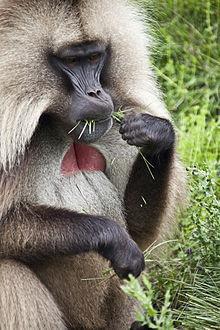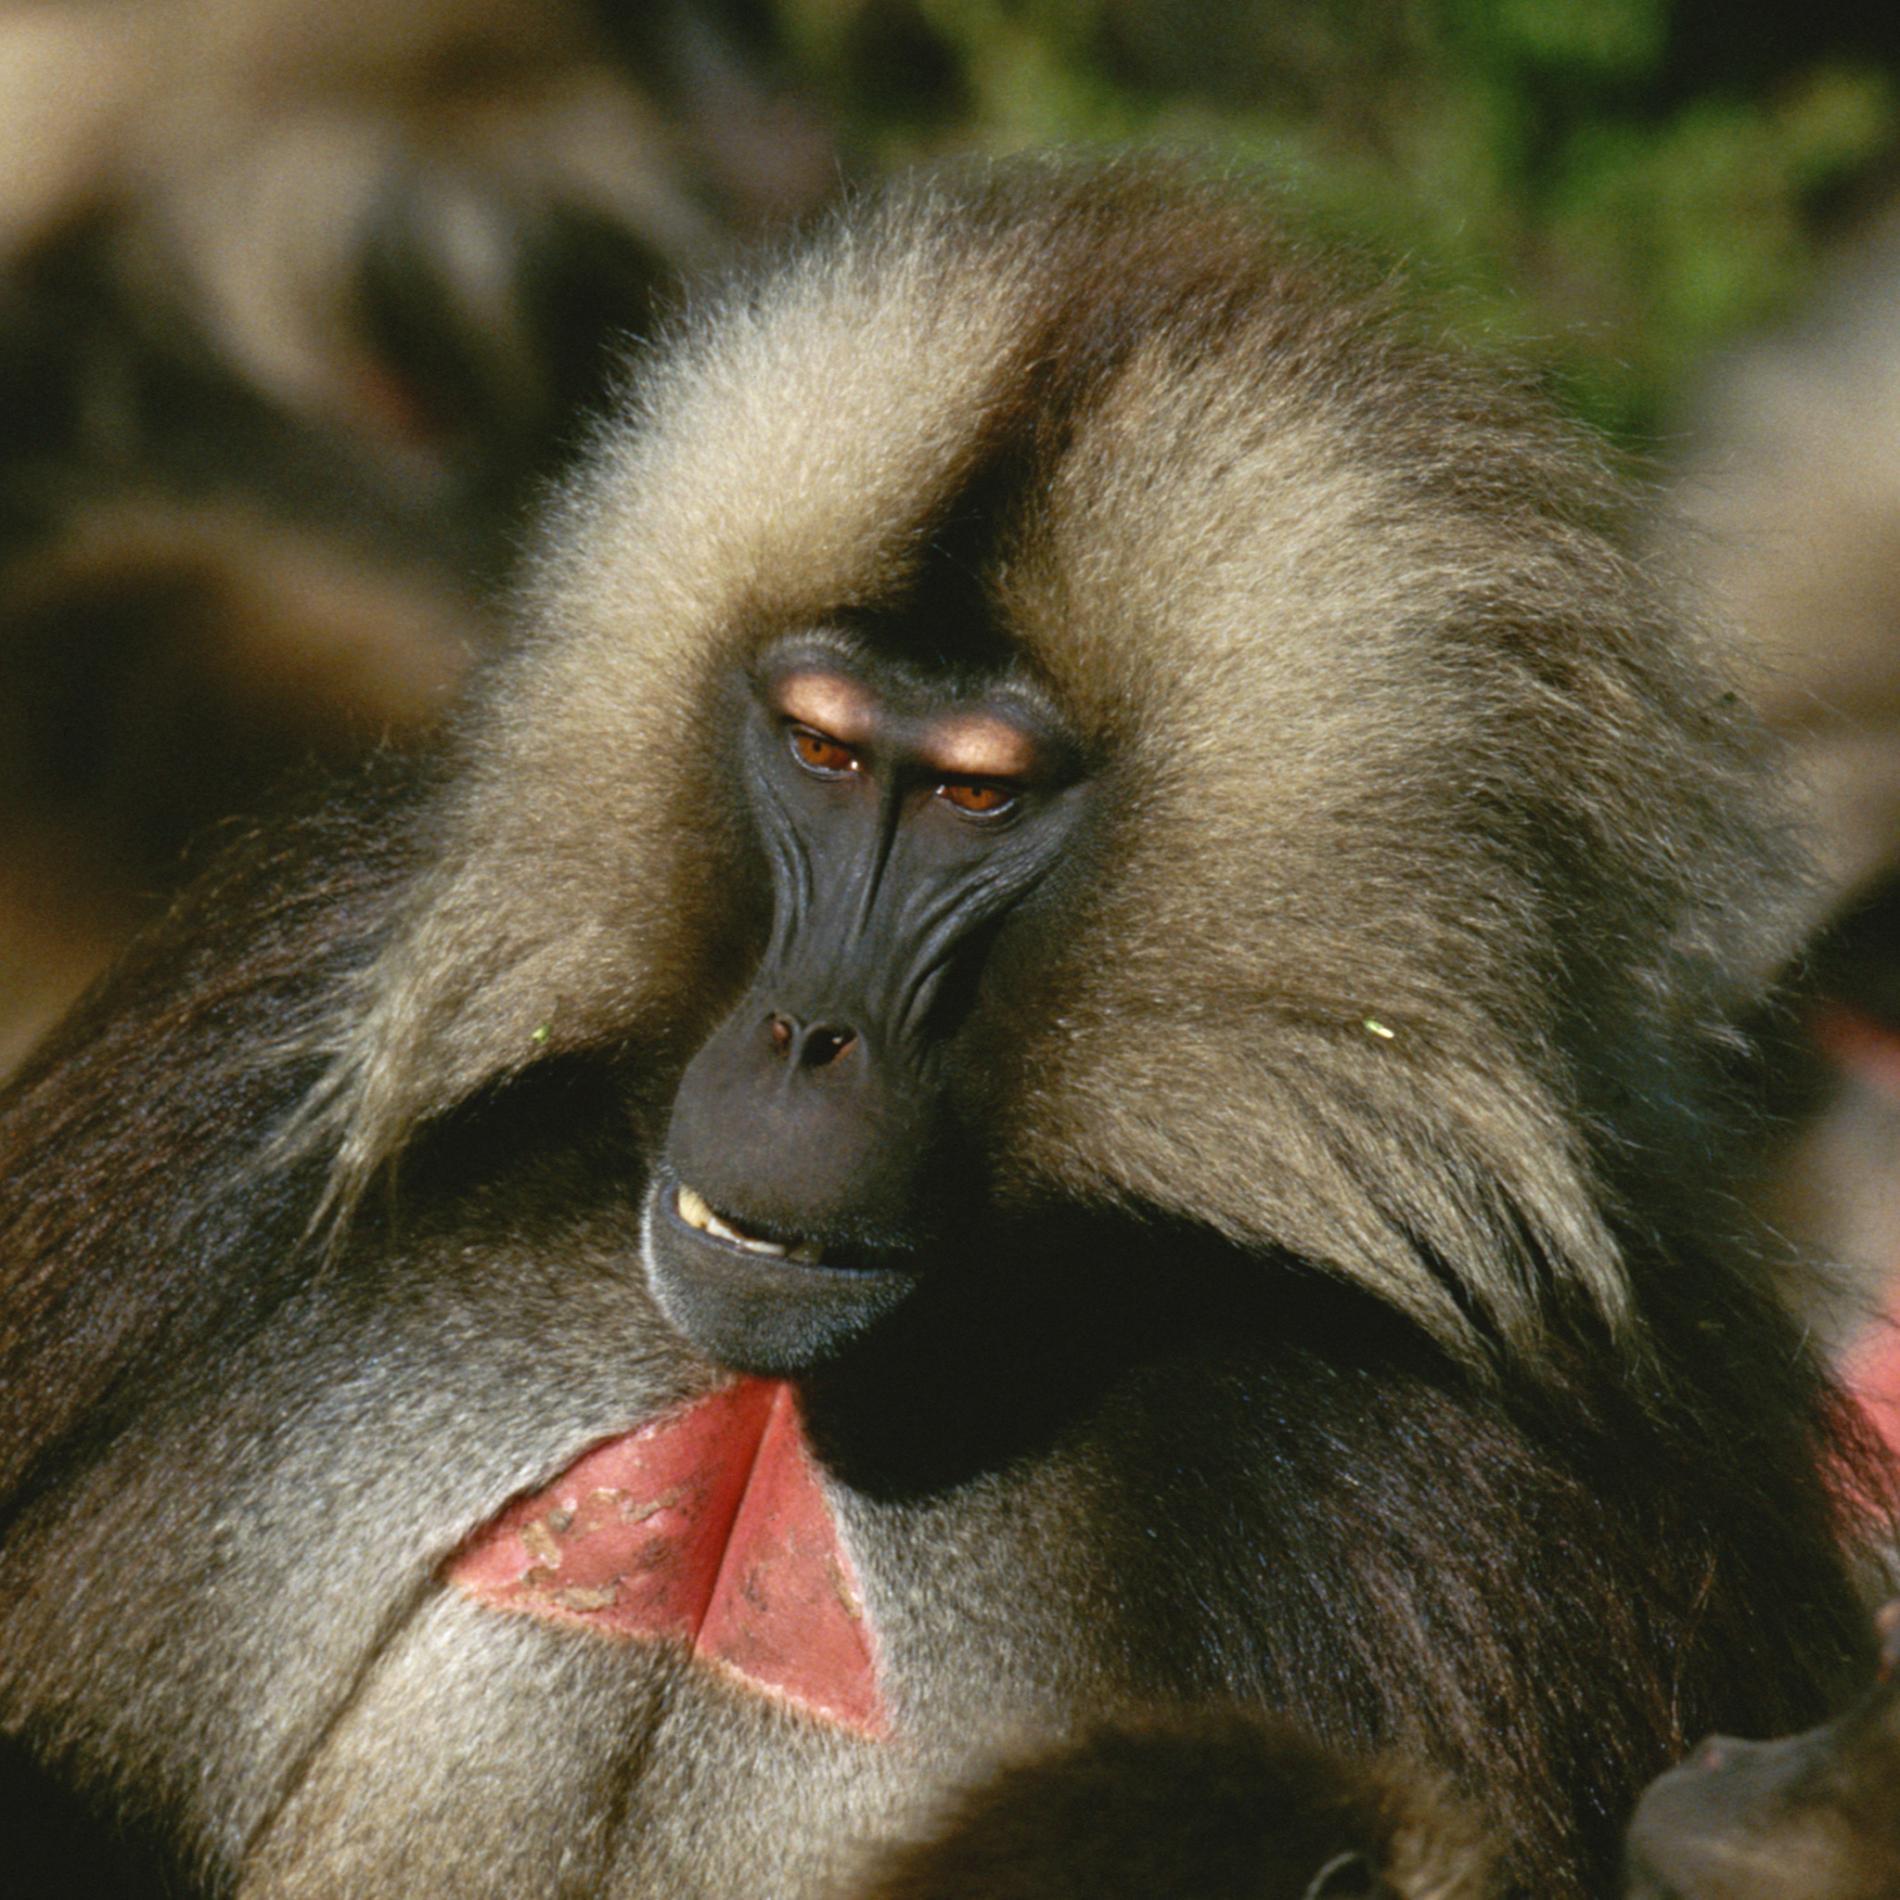The first image is the image on the left, the second image is the image on the right. Considering the images on both sides, is "There is a total of 1 baboon eating while sitting down." valid? Answer yes or no. Yes. The first image is the image on the left, the second image is the image on the right. Examine the images to the left and right. Is the description "in the right pic the fangs of the monkey is shown" accurate? Answer yes or no. No. 